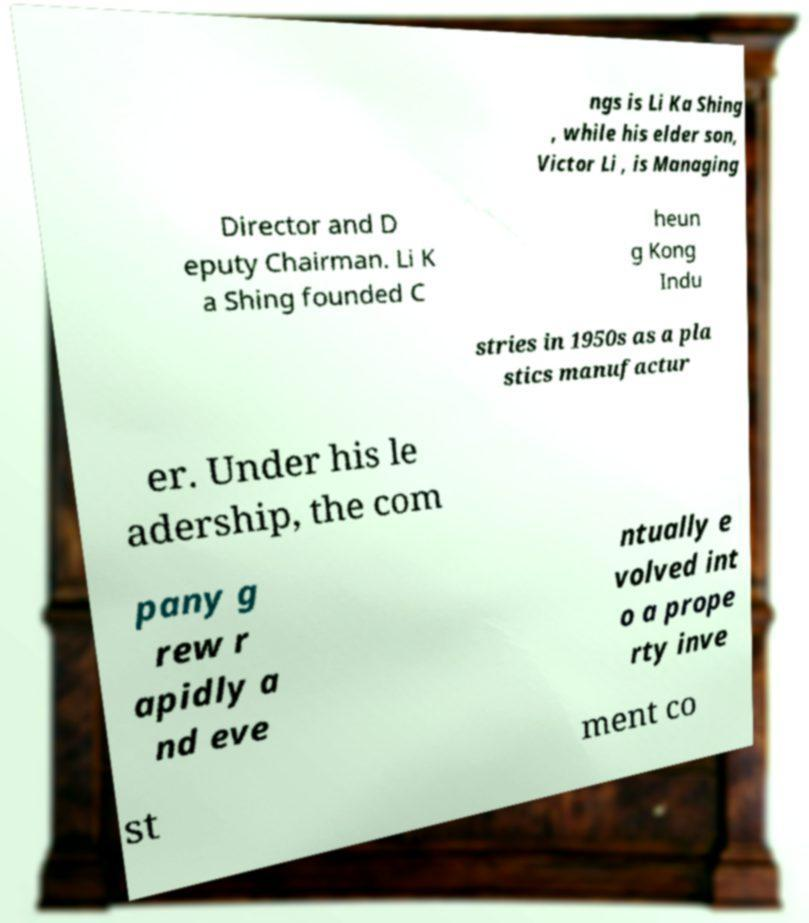Can you read and provide the text displayed in the image?This photo seems to have some interesting text. Can you extract and type it out for me? ngs is Li Ka Shing , while his elder son, Victor Li , is Managing Director and D eputy Chairman. Li K a Shing founded C heun g Kong Indu stries in 1950s as a pla stics manufactur er. Under his le adership, the com pany g rew r apidly a nd eve ntually e volved int o a prope rty inve st ment co 